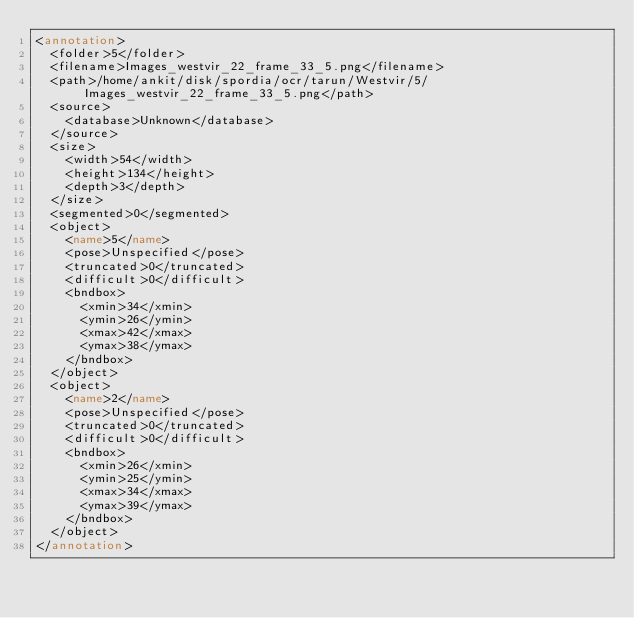Convert code to text. <code><loc_0><loc_0><loc_500><loc_500><_XML_><annotation>
	<folder>5</folder>
	<filename>Images_westvir_22_frame_33_5.png</filename>
	<path>/home/ankit/disk/spordia/ocr/tarun/Westvir/5/Images_westvir_22_frame_33_5.png</path>
	<source>
		<database>Unknown</database>
	</source>
	<size>
		<width>54</width>
		<height>134</height>
		<depth>3</depth>
	</size>
	<segmented>0</segmented>
	<object>
		<name>5</name>
		<pose>Unspecified</pose>
		<truncated>0</truncated>
		<difficult>0</difficult>
		<bndbox>
			<xmin>34</xmin>
			<ymin>26</ymin>
			<xmax>42</xmax>
			<ymax>38</ymax>
		</bndbox>
	</object>
	<object>
		<name>2</name>
		<pose>Unspecified</pose>
		<truncated>0</truncated>
		<difficult>0</difficult>
		<bndbox>
			<xmin>26</xmin>
			<ymin>25</ymin>
			<xmax>34</xmax>
			<ymax>39</ymax>
		</bndbox>
	</object>
</annotation>
</code> 